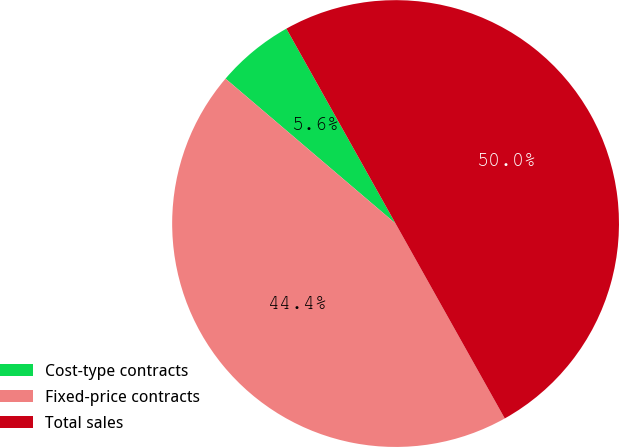Convert chart. <chart><loc_0><loc_0><loc_500><loc_500><pie_chart><fcel>Cost-type contracts<fcel>Fixed-price contracts<fcel>Total sales<nl><fcel>5.64%<fcel>44.36%<fcel>50.0%<nl></chart> 